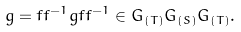<formula> <loc_0><loc_0><loc_500><loc_500>g = f f ^ { - 1 } g f f ^ { - 1 } \in G _ { ( T ) } G _ { ( S ) } G _ { ( T ) } .</formula> 